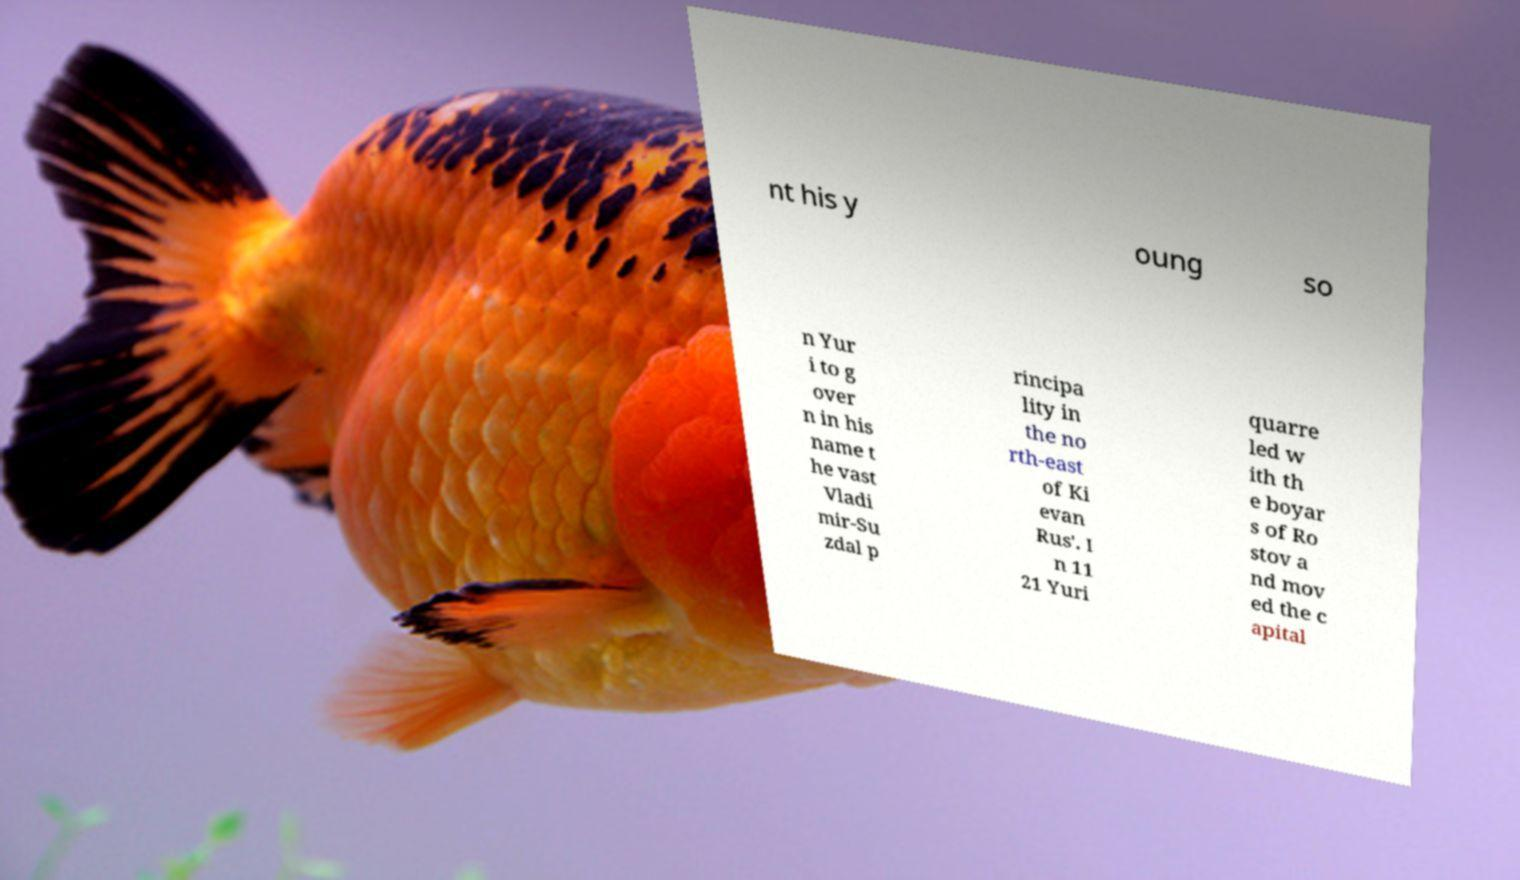Please read and relay the text visible in this image. What does it say? nt his y oung so n Yur i to g over n in his name t he vast Vladi mir-Su zdal p rincipa lity in the no rth-east of Ki evan Rus'. I n 11 21 Yuri quarre led w ith th e boyar s of Ro stov a nd mov ed the c apital 